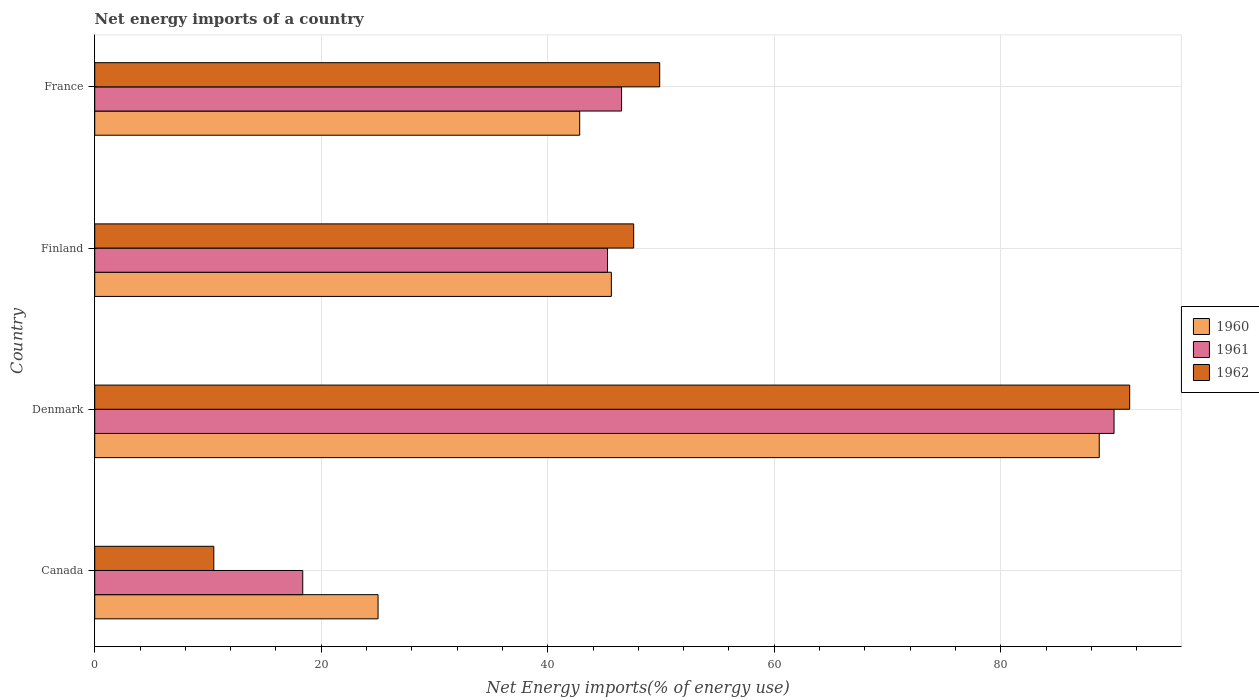How many groups of bars are there?
Offer a terse response. 4. Are the number of bars per tick equal to the number of legend labels?
Make the answer very short. Yes. What is the label of the 3rd group of bars from the top?
Make the answer very short. Denmark. In how many cases, is the number of bars for a given country not equal to the number of legend labels?
Keep it short and to the point. 0. What is the net energy imports in 1962 in Denmark?
Your answer should be very brief. 91.39. Across all countries, what is the maximum net energy imports in 1961?
Your answer should be compact. 90.01. Across all countries, what is the minimum net energy imports in 1961?
Your response must be concise. 18.37. In which country was the net energy imports in 1960 minimum?
Your answer should be very brief. Canada. What is the total net energy imports in 1960 in the graph?
Offer a very short reply. 202.16. What is the difference between the net energy imports in 1960 in Canada and that in Denmark?
Provide a short and direct response. -63.68. What is the difference between the net energy imports in 1961 in Denmark and the net energy imports in 1962 in Finland?
Offer a terse response. 42.42. What is the average net energy imports in 1960 per country?
Provide a short and direct response. 50.54. What is the difference between the net energy imports in 1962 and net energy imports in 1960 in Denmark?
Your answer should be very brief. 2.69. In how many countries, is the net energy imports in 1961 greater than 68 %?
Provide a short and direct response. 1. What is the ratio of the net energy imports in 1960 in Canada to that in France?
Offer a terse response. 0.58. What is the difference between the highest and the second highest net energy imports in 1960?
Offer a very short reply. 43.08. What is the difference between the highest and the lowest net energy imports in 1960?
Ensure brevity in your answer.  63.68. In how many countries, is the net energy imports in 1960 greater than the average net energy imports in 1960 taken over all countries?
Keep it short and to the point. 1. What does the 3rd bar from the top in Canada represents?
Make the answer very short. 1960. What does the 3rd bar from the bottom in Canada represents?
Make the answer very short. 1962. Is it the case that in every country, the sum of the net energy imports in 1960 and net energy imports in 1962 is greater than the net energy imports in 1961?
Ensure brevity in your answer.  Yes. How many bars are there?
Ensure brevity in your answer.  12. Are all the bars in the graph horizontal?
Give a very brief answer. Yes. How many countries are there in the graph?
Ensure brevity in your answer.  4. What is the difference between two consecutive major ticks on the X-axis?
Give a very brief answer. 20. Does the graph contain any zero values?
Make the answer very short. No. How many legend labels are there?
Your response must be concise. 3. How are the legend labels stacked?
Offer a very short reply. Vertical. What is the title of the graph?
Give a very brief answer. Net energy imports of a country. What is the label or title of the X-axis?
Offer a terse response. Net Energy imports(% of energy use). What is the Net Energy imports(% of energy use) in 1960 in Canada?
Provide a short and direct response. 25.02. What is the Net Energy imports(% of energy use) of 1961 in Canada?
Give a very brief answer. 18.37. What is the Net Energy imports(% of energy use) in 1962 in Canada?
Your response must be concise. 10.52. What is the Net Energy imports(% of energy use) in 1960 in Denmark?
Provide a succinct answer. 88.7. What is the Net Energy imports(% of energy use) of 1961 in Denmark?
Provide a succinct answer. 90.01. What is the Net Energy imports(% of energy use) of 1962 in Denmark?
Make the answer very short. 91.39. What is the Net Energy imports(% of energy use) of 1960 in Finland?
Your answer should be compact. 45.62. What is the Net Energy imports(% of energy use) in 1961 in Finland?
Your response must be concise. 45.28. What is the Net Energy imports(% of energy use) of 1962 in Finland?
Provide a short and direct response. 47.59. What is the Net Energy imports(% of energy use) in 1960 in France?
Provide a succinct answer. 42.82. What is the Net Energy imports(% of energy use) in 1961 in France?
Give a very brief answer. 46.52. What is the Net Energy imports(% of energy use) in 1962 in France?
Your answer should be compact. 49.89. Across all countries, what is the maximum Net Energy imports(% of energy use) in 1960?
Offer a very short reply. 88.7. Across all countries, what is the maximum Net Energy imports(% of energy use) in 1961?
Make the answer very short. 90.01. Across all countries, what is the maximum Net Energy imports(% of energy use) of 1962?
Give a very brief answer. 91.39. Across all countries, what is the minimum Net Energy imports(% of energy use) in 1960?
Ensure brevity in your answer.  25.02. Across all countries, what is the minimum Net Energy imports(% of energy use) in 1961?
Make the answer very short. 18.37. Across all countries, what is the minimum Net Energy imports(% of energy use) of 1962?
Provide a short and direct response. 10.52. What is the total Net Energy imports(% of energy use) in 1960 in the graph?
Keep it short and to the point. 202.16. What is the total Net Energy imports(% of energy use) in 1961 in the graph?
Offer a terse response. 200.18. What is the total Net Energy imports(% of energy use) in 1962 in the graph?
Keep it short and to the point. 199.38. What is the difference between the Net Energy imports(% of energy use) in 1960 in Canada and that in Denmark?
Offer a very short reply. -63.68. What is the difference between the Net Energy imports(% of energy use) in 1961 in Canada and that in Denmark?
Your response must be concise. -71.64. What is the difference between the Net Energy imports(% of energy use) in 1962 in Canada and that in Denmark?
Make the answer very short. -80.87. What is the difference between the Net Energy imports(% of energy use) in 1960 in Canada and that in Finland?
Offer a terse response. -20.6. What is the difference between the Net Energy imports(% of energy use) in 1961 in Canada and that in Finland?
Ensure brevity in your answer.  -26.91. What is the difference between the Net Energy imports(% of energy use) in 1962 in Canada and that in Finland?
Keep it short and to the point. -37.08. What is the difference between the Net Energy imports(% of energy use) of 1960 in Canada and that in France?
Provide a succinct answer. -17.8. What is the difference between the Net Energy imports(% of energy use) of 1961 in Canada and that in France?
Your answer should be compact. -28.15. What is the difference between the Net Energy imports(% of energy use) in 1962 in Canada and that in France?
Your response must be concise. -39.37. What is the difference between the Net Energy imports(% of energy use) in 1960 in Denmark and that in Finland?
Give a very brief answer. 43.08. What is the difference between the Net Energy imports(% of energy use) of 1961 in Denmark and that in Finland?
Offer a very short reply. 44.73. What is the difference between the Net Energy imports(% of energy use) of 1962 in Denmark and that in Finland?
Keep it short and to the point. 43.8. What is the difference between the Net Energy imports(% of energy use) in 1960 in Denmark and that in France?
Provide a succinct answer. 45.88. What is the difference between the Net Energy imports(% of energy use) in 1961 in Denmark and that in France?
Keep it short and to the point. 43.49. What is the difference between the Net Energy imports(% of energy use) in 1962 in Denmark and that in France?
Your response must be concise. 41.5. What is the difference between the Net Energy imports(% of energy use) in 1960 in Finland and that in France?
Provide a succinct answer. 2.8. What is the difference between the Net Energy imports(% of energy use) in 1961 in Finland and that in France?
Keep it short and to the point. -1.24. What is the difference between the Net Energy imports(% of energy use) of 1962 in Finland and that in France?
Your response must be concise. -2.3. What is the difference between the Net Energy imports(% of energy use) in 1960 in Canada and the Net Energy imports(% of energy use) in 1961 in Denmark?
Your answer should be compact. -64.99. What is the difference between the Net Energy imports(% of energy use) in 1960 in Canada and the Net Energy imports(% of energy use) in 1962 in Denmark?
Offer a terse response. -66.37. What is the difference between the Net Energy imports(% of energy use) of 1961 in Canada and the Net Energy imports(% of energy use) of 1962 in Denmark?
Your response must be concise. -73.02. What is the difference between the Net Energy imports(% of energy use) in 1960 in Canada and the Net Energy imports(% of energy use) in 1961 in Finland?
Offer a very short reply. -20.26. What is the difference between the Net Energy imports(% of energy use) of 1960 in Canada and the Net Energy imports(% of energy use) of 1962 in Finland?
Your answer should be compact. -22.57. What is the difference between the Net Energy imports(% of energy use) in 1961 in Canada and the Net Energy imports(% of energy use) in 1962 in Finland?
Offer a very short reply. -29.22. What is the difference between the Net Energy imports(% of energy use) in 1960 in Canada and the Net Energy imports(% of energy use) in 1961 in France?
Ensure brevity in your answer.  -21.5. What is the difference between the Net Energy imports(% of energy use) in 1960 in Canada and the Net Energy imports(% of energy use) in 1962 in France?
Offer a very short reply. -24.87. What is the difference between the Net Energy imports(% of energy use) of 1961 in Canada and the Net Energy imports(% of energy use) of 1962 in France?
Your answer should be very brief. -31.52. What is the difference between the Net Energy imports(% of energy use) of 1960 in Denmark and the Net Energy imports(% of energy use) of 1961 in Finland?
Keep it short and to the point. 43.42. What is the difference between the Net Energy imports(% of energy use) of 1960 in Denmark and the Net Energy imports(% of energy use) of 1962 in Finland?
Give a very brief answer. 41.11. What is the difference between the Net Energy imports(% of energy use) of 1961 in Denmark and the Net Energy imports(% of energy use) of 1962 in Finland?
Offer a very short reply. 42.42. What is the difference between the Net Energy imports(% of energy use) of 1960 in Denmark and the Net Energy imports(% of energy use) of 1961 in France?
Keep it short and to the point. 42.18. What is the difference between the Net Energy imports(% of energy use) in 1960 in Denmark and the Net Energy imports(% of energy use) in 1962 in France?
Your answer should be compact. 38.81. What is the difference between the Net Energy imports(% of energy use) in 1961 in Denmark and the Net Energy imports(% of energy use) in 1962 in France?
Provide a short and direct response. 40.12. What is the difference between the Net Energy imports(% of energy use) in 1960 in Finland and the Net Energy imports(% of energy use) in 1961 in France?
Give a very brief answer. -0.9. What is the difference between the Net Energy imports(% of energy use) of 1960 in Finland and the Net Energy imports(% of energy use) of 1962 in France?
Provide a succinct answer. -4.27. What is the difference between the Net Energy imports(% of energy use) in 1961 in Finland and the Net Energy imports(% of energy use) in 1962 in France?
Offer a terse response. -4.61. What is the average Net Energy imports(% of energy use) in 1960 per country?
Keep it short and to the point. 50.54. What is the average Net Energy imports(% of energy use) in 1961 per country?
Make the answer very short. 50.04. What is the average Net Energy imports(% of energy use) of 1962 per country?
Your response must be concise. 49.85. What is the difference between the Net Energy imports(% of energy use) of 1960 and Net Energy imports(% of energy use) of 1961 in Canada?
Give a very brief answer. 6.65. What is the difference between the Net Energy imports(% of energy use) in 1960 and Net Energy imports(% of energy use) in 1962 in Canada?
Your answer should be compact. 14.5. What is the difference between the Net Energy imports(% of energy use) in 1961 and Net Energy imports(% of energy use) in 1962 in Canada?
Give a very brief answer. 7.85. What is the difference between the Net Energy imports(% of energy use) of 1960 and Net Energy imports(% of energy use) of 1961 in Denmark?
Offer a very short reply. -1.31. What is the difference between the Net Energy imports(% of energy use) in 1960 and Net Energy imports(% of energy use) in 1962 in Denmark?
Offer a terse response. -2.69. What is the difference between the Net Energy imports(% of energy use) in 1961 and Net Energy imports(% of energy use) in 1962 in Denmark?
Make the answer very short. -1.38. What is the difference between the Net Energy imports(% of energy use) in 1960 and Net Energy imports(% of energy use) in 1961 in Finland?
Make the answer very short. 0.34. What is the difference between the Net Energy imports(% of energy use) in 1960 and Net Energy imports(% of energy use) in 1962 in Finland?
Provide a short and direct response. -1.97. What is the difference between the Net Energy imports(% of energy use) of 1961 and Net Energy imports(% of energy use) of 1962 in Finland?
Make the answer very short. -2.31. What is the difference between the Net Energy imports(% of energy use) of 1960 and Net Energy imports(% of energy use) of 1961 in France?
Offer a terse response. -3.7. What is the difference between the Net Energy imports(% of energy use) in 1960 and Net Energy imports(% of energy use) in 1962 in France?
Provide a succinct answer. -7.06. What is the difference between the Net Energy imports(% of energy use) in 1961 and Net Energy imports(% of energy use) in 1962 in France?
Offer a terse response. -3.37. What is the ratio of the Net Energy imports(% of energy use) of 1960 in Canada to that in Denmark?
Offer a very short reply. 0.28. What is the ratio of the Net Energy imports(% of energy use) of 1961 in Canada to that in Denmark?
Keep it short and to the point. 0.2. What is the ratio of the Net Energy imports(% of energy use) in 1962 in Canada to that in Denmark?
Make the answer very short. 0.12. What is the ratio of the Net Energy imports(% of energy use) in 1960 in Canada to that in Finland?
Offer a very short reply. 0.55. What is the ratio of the Net Energy imports(% of energy use) of 1961 in Canada to that in Finland?
Your answer should be compact. 0.41. What is the ratio of the Net Energy imports(% of energy use) of 1962 in Canada to that in Finland?
Offer a terse response. 0.22. What is the ratio of the Net Energy imports(% of energy use) in 1960 in Canada to that in France?
Give a very brief answer. 0.58. What is the ratio of the Net Energy imports(% of energy use) of 1961 in Canada to that in France?
Offer a terse response. 0.39. What is the ratio of the Net Energy imports(% of energy use) of 1962 in Canada to that in France?
Make the answer very short. 0.21. What is the ratio of the Net Energy imports(% of energy use) of 1960 in Denmark to that in Finland?
Give a very brief answer. 1.94. What is the ratio of the Net Energy imports(% of energy use) in 1961 in Denmark to that in Finland?
Your answer should be very brief. 1.99. What is the ratio of the Net Energy imports(% of energy use) in 1962 in Denmark to that in Finland?
Your answer should be very brief. 1.92. What is the ratio of the Net Energy imports(% of energy use) in 1960 in Denmark to that in France?
Keep it short and to the point. 2.07. What is the ratio of the Net Energy imports(% of energy use) in 1961 in Denmark to that in France?
Give a very brief answer. 1.93. What is the ratio of the Net Energy imports(% of energy use) in 1962 in Denmark to that in France?
Make the answer very short. 1.83. What is the ratio of the Net Energy imports(% of energy use) in 1960 in Finland to that in France?
Offer a terse response. 1.07. What is the ratio of the Net Energy imports(% of energy use) of 1961 in Finland to that in France?
Make the answer very short. 0.97. What is the ratio of the Net Energy imports(% of energy use) of 1962 in Finland to that in France?
Your answer should be compact. 0.95. What is the difference between the highest and the second highest Net Energy imports(% of energy use) of 1960?
Offer a terse response. 43.08. What is the difference between the highest and the second highest Net Energy imports(% of energy use) in 1961?
Your response must be concise. 43.49. What is the difference between the highest and the second highest Net Energy imports(% of energy use) in 1962?
Ensure brevity in your answer.  41.5. What is the difference between the highest and the lowest Net Energy imports(% of energy use) in 1960?
Ensure brevity in your answer.  63.68. What is the difference between the highest and the lowest Net Energy imports(% of energy use) in 1961?
Provide a short and direct response. 71.64. What is the difference between the highest and the lowest Net Energy imports(% of energy use) in 1962?
Ensure brevity in your answer.  80.87. 